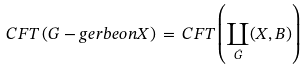Convert formula to latex. <formula><loc_0><loc_0><loc_500><loc_500>C F T \left ( G - g e r b e o n X \right ) \, = \, C F T \left ( \coprod _ { \hat { G } } ( X , B ) \right )</formula> 